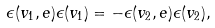<formula> <loc_0><loc_0><loc_500><loc_500>\epsilon ( v _ { 1 } , e ) \epsilon ( v _ { 1 } ) = - \epsilon ( v _ { 2 } , e ) \epsilon ( v _ { 2 } ) ,</formula> 